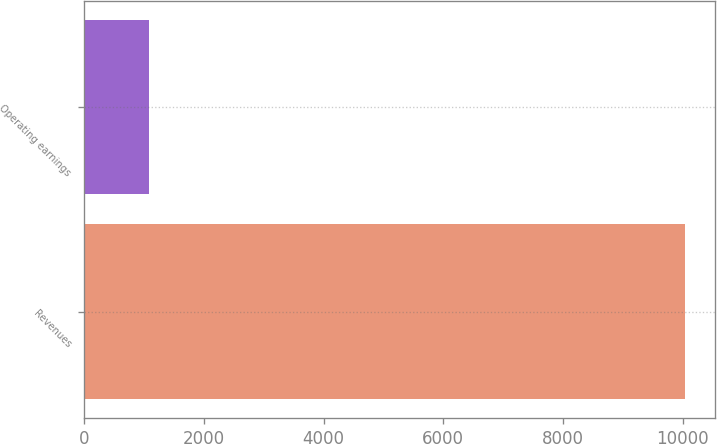Convert chart to OTSL. <chart><loc_0><loc_0><loc_500><loc_500><bar_chart><fcel>Revenues<fcel>Operating earnings<nl><fcel>10038<fcel>1075<nl></chart> 